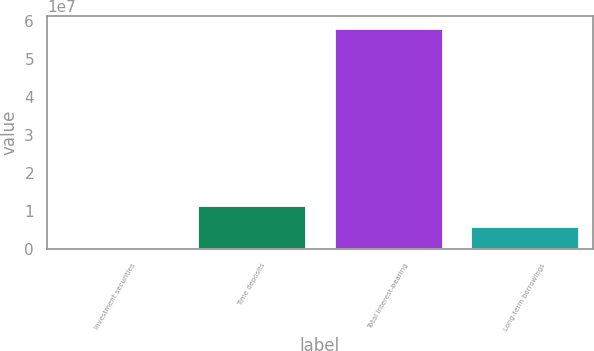<chart> <loc_0><loc_0><loc_500><loc_500><bar_chart><fcel>Investment securities<fcel>Time deposits<fcel>Total interest-bearing<fcel>Long-term borrowings<nl><fcel>642272<fcel>1.15242e+07<fcel>5.81549e+07<fcel>6.08325e+06<nl></chart> 